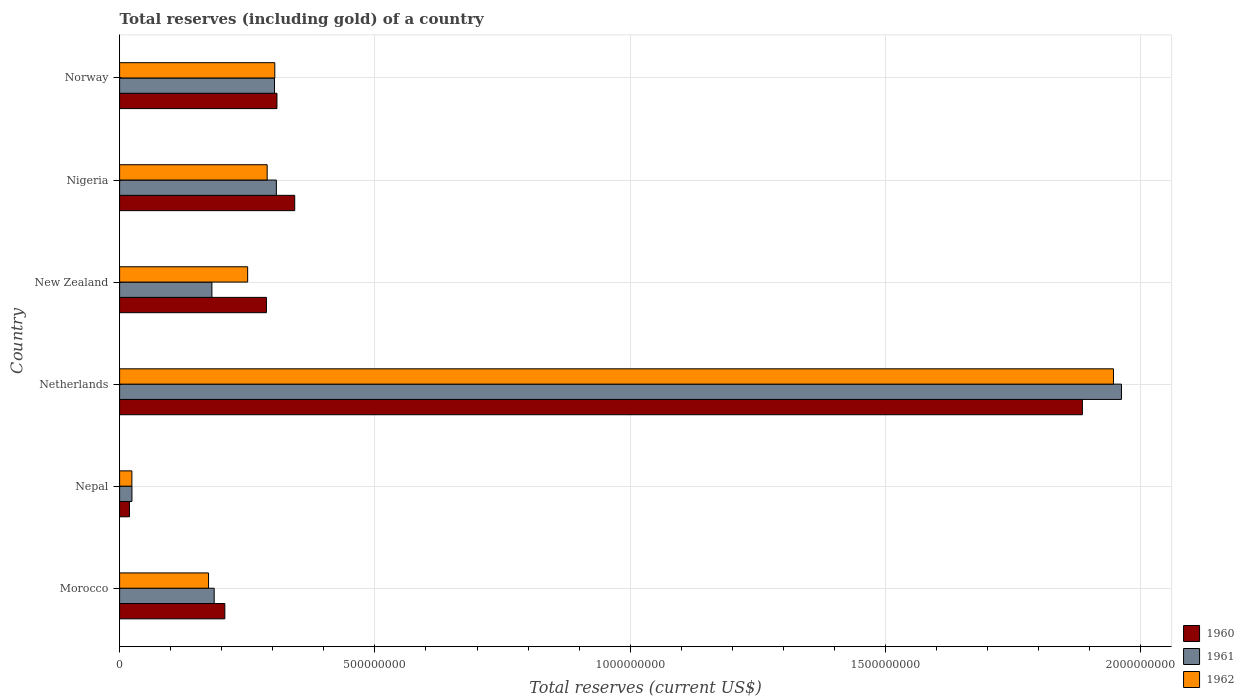How many groups of bars are there?
Provide a short and direct response. 6. How many bars are there on the 3rd tick from the bottom?
Ensure brevity in your answer.  3. What is the total reserves (including gold) in 1961 in Norway?
Provide a succinct answer. 3.03e+08. Across all countries, what is the maximum total reserves (including gold) in 1961?
Offer a terse response. 1.96e+09. Across all countries, what is the minimum total reserves (including gold) in 1960?
Your answer should be very brief. 1.93e+07. In which country was the total reserves (including gold) in 1961 minimum?
Give a very brief answer. Nepal. What is the total total reserves (including gold) in 1961 in the graph?
Your response must be concise. 2.96e+09. What is the difference between the total reserves (including gold) in 1962 in Nigeria and that in Norway?
Make the answer very short. -1.50e+07. What is the difference between the total reserves (including gold) in 1961 in Netherlands and the total reserves (including gold) in 1960 in Nepal?
Make the answer very short. 1.94e+09. What is the average total reserves (including gold) in 1960 per country?
Keep it short and to the point. 5.08e+08. What is the difference between the total reserves (including gold) in 1961 and total reserves (including gold) in 1960 in Nepal?
Your answer should be very brief. 4.88e+06. What is the ratio of the total reserves (including gold) in 1961 in Morocco to that in Norway?
Your answer should be compact. 0.61. Is the total reserves (including gold) in 1961 in Morocco less than that in Nigeria?
Offer a terse response. Yes. Is the difference between the total reserves (including gold) in 1961 in Nepal and Norway greater than the difference between the total reserves (including gold) in 1960 in Nepal and Norway?
Ensure brevity in your answer.  Yes. What is the difference between the highest and the second highest total reserves (including gold) in 1961?
Offer a terse response. 1.66e+09. What is the difference between the highest and the lowest total reserves (including gold) in 1962?
Keep it short and to the point. 1.92e+09. In how many countries, is the total reserves (including gold) in 1961 greater than the average total reserves (including gold) in 1961 taken over all countries?
Keep it short and to the point. 1. What does the 1st bar from the top in Netherlands represents?
Ensure brevity in your answer.  1962. What does the 2nd bar from the bottom in Netherlands represents?
Give a very brief answer. 1961. Is it the case that in every country, the sum of the total reserves (including gold) in 1962 and total reserves (including gold) in 1961 is greater than the total reserves (including gold) in 1960?
Keep it short and to the point. Yes. How many bars are there?
Provide a short and direct response. 18. What is the difference between two consecutive major ticks on the X-axis?
Your response must be concise. 5.00e+08. Does the graph contain any zero values?
Keep it short and to the point. No. How are the legend labels stacked?
Provide a short and direct response. Vertical. What is the title of the graph?
Make the answer very short. Total reserves (including gold) of a country. What is the label or title of the X-axis?
Your answer should be very brief. Total reserves (current US$). What is the label or title of the Y-axis?
Your answer should be compact. Country. What is the Total reserves (current US$) of 1960 in Morocco?
Provide a succinct answer. 2.06e+08. What is the Total reserves (current US$) of 1961 in Morocco?
Your answer should be very brief. 1.85e+08. What is the Total reserves (current US$) in 1962 in Morocco?
Keep it short and to the point. 1.74e+08. What is the Total reserves (current US$) of 1960 in Nepal?
Keep it short and to the point. 1.93e+07. What is the Total reserves (current US$) of 1961 in Nepal?
Provide a short and direct response. 2.41e+07. What is the Total reserves (current US$) of 1962 in Nepal?
Ensure brevity in your answer.  2.40e+07. What is the Total reserves (current US$) in 1960 in Netherlands?
Offer a very short reply. 1.89e+09. What is the Total reserves (current US$) in 1961 in Netherlands?
Give a very brief answer. 1.96e+09. What is the Total reserves (current US$) of 1962 in Netherlands?
Ensure brevity in your answer.  1.95e+09. What is the Total reserves (current US$) of 1960 in New Zealand?
Your response must be concise. 2.88e+08. What is the Total reserves (current US$) in 1961 in New Zealand?
Provide a short and direct response. 1.81e+08. What is the Total reserves (current US$) in 1962 in New Zealand?
Offer a very short reply. 2.51e+08. What is the Total reserves (current US$) in 1960 in Nigeria?
Offer a terse response. 3.43e+08. What is the Total reserves (current US$) of 1961 in Nigeria?
Offer a very short reply. 3.07e+08. What is the Total reserves (current US$) in 1962 in Nigeria?
Make the answer very short. 2.89e+08. What is the Total reserves (current US$) of 1960 in Norway?
Your response must be concise. 3.08e+08. What is the Total reserves (current US$) of 1961 in Norway?
Offer a very short reply. 3.03e+08. What is the Total reserves (current US$) in 1962 in Norway?
Ensure brevity in your answer.  3.04e+08. Across all countries, what is the maximum Total reserves (current US$) of 1960?
Offer a very short reply. 1.89e+09. Across all countries, what is the maximum Total reserves (current US$) in 1961?
Make the answer very short. 1.96e+09. Across all countries, what is the maximum Total reserves (current US$) of 1962?
Your answer should be compact. 1.95e+09. Across all countries, what is the minimum Total reserves (current US$) in 1960?
Your answer should be very brief. 1.93e+07. Across all countries, what is the minimum Total reserves (current US$) of 1961?
Your response must be concise. 2.41e+07. Across all countries, what is the minimum Total reserves (current US$) of 1962?
Provide a succinct answer. 2.40e+07. What is the total Total reserves (current US$) in 1960 in the graph?
Your answer should be compact. 3.05e+09. What is the total Total reserves (current US$) in 1961 in the graph?
Ensure brevity in your answer.  2.96e+09. What is the total Total reserves (current US$) of 1962 in the graph?
Give a very brief answer. 2.99e+09. What is the difference between the Total reserves (current US$) of 1960 in Morocco and that in Nepal?
Provide a short and direct response. 1.87e+08. What is the difference between the Total reserves (current US$) in 1961 in Morocco and that in Nepal?
Your response must be concise. 1.61e+08. What is the difference between the Total reserves (current US$) of 1962 in Morocco and that in Nepal?
Provide a succinct answer. 1.50e+08. What is the difference between the Total reserves (current US$) of 1960 in Morocco and that in Netherlands?
Your response must be concise. -1.68e+09. What is the difference between the Total reserves (current US$) of 1961 in Morocco and that in Netherlands?
Your response must be concise. -1.78e+09. What is the difference between the Total reserves (current US$) in 1962 in Morocco and that in Netherlands?
Ensure brevity in your answer.  -1.77e+09. What is the difference between the Total reserves (current US$) of 1960 in Morocco and that in New Zealand?
Provide a succinct answer. -8.15e+07. What is the difference between the Total reserves (current US$) of 1961 in Morocco and that in New Zealand?
Ensure brevity in your answer.  4.47e+06. What is the difference between the Total reserves (current US$) in 1962 in Morocco and that in New Zealand?
Provide a short and direct response. -7.66e+07. What is the difference between the Total reserves (current US$) in 1960 in Morocco and that in Nigeria?
Offer a very short reply. -1.37e+08. What is the difference between the Total reserves (current US$) in 1961 in Morocco and that in Nigeria?
Ensure brevity in your answer.  -1.22e+08. What is the difference between the Total reserves (current US$) in 1962 in Morocco and that in Nigeria?
Your answer should be compact. -1.15e+08. What is the difference between the Total reserves (current US$) of 1960 in Morocco and that in Norway?
Provide a succinct answer. -1.02e+08. What is the difference between the Total reserves (current US$) of 1961 in Morocco and that in Norway?
Give a very brief answer. -1.18e+08. What is the difference between the Total reserves (current US$) in 1962 in Morocco and that in Norway?
Provide a succinct answer. -1.30e+08. What is the difference between the Total reserves (current US$) in 1960 in Nepal and that in Netherlands?
Provide a succinct answer. -1.87e+09. What is the difference between the Total reserves (current US$) of 1961 in Nepal and that in Netherlands?
Offer a very short reply. -1.94e+09. What is the difference between the Total reserves (current US$) of 1962 in Nepal and that in Netherlands?
Offer a terse response. -1.92e+09. What is the difference between the Total reserves (current US$) in 1960 in Nepal and that in New Zealand?
Your answer should be very brief. -2.68e+08. What is the difference between the Total reserves (current US$) of 1961 in Nepal and that in New Zealand?
Your answer should be very brief. -1.57e+08. What is the difference between the Total reserves (current US$) of 1962 in Nepal and that in New Zealand?
Your answer should be very brief. -2.27e+08. What is the difference between the Total reserves (current US$) of 1960 in Nepal and that in Nigeria?
Keep it short and to the point. -3.24e+08. What is the difference between the Total reserves (current US$) of 1961 in Nepal and that in Nigeria?
Keep it short and to the point. -2.83e+08. What is the difference between the Total reserves (current US$) in 1962 in Nepal and that in Nigeria?
Ensure brevity in your answer.  -2.65e+08. What is the difference between the Total reserves (current US$) of 1960 in Nepal and that in Norway?
Give a very brief answer. -2.89e+08. What is the difference between the Total reserves (current US$) in 1961 in Nepal and that in Norway?
Ensure brevity in your answer.  -2.79e+08. What is the difference between the Total reserves (current US$) in 1962 in Nepal and that in Norway?
Provide a succinct answer. -2.80e+08. What is the difference between the Total reserves (current US$) in 1960 in Netherlands and that in New Zealand?
Your answer should be very brief. 1.60e+09. What is the difference between the Total reserves (current US$) of 1961 in Netherlands and that in New Zealand?
Offer a terse response. 1.78e+09. What is the difference between the Total reserves (current US$) in 1962 in Netherlands and that in New Zealand?
Your response must be concise. 1.70e+09. What is the difference between the Total reserves (current US$) in 1960 in Netherlands and that in Nigeria?
Offer a very short reply. 1.54e+09. What is the difference between the Total reserves (current US$) of 1961 in Netherlands and that in Nigeria?
Offer a very short reply. 1.66e+09. What is the difference between the Total reserves (current US$) of 1962 in Netherlands and that in Nigeria?
Your answer should be very brief. 1.66e+09. What is the difference between the Total reserves (current US$) of 1960 in Netherlands and that in Norway?
Keep it short and to the point. 1.58e+09. What is the difference between the Total reserves (current US$) in 1961 in Netherlands and that in Norway?
Offer a very short reply. 1.66e+09. What is the difference between the Total reserves (current US$) in 1962 in Netherlands and that in Norway?
Ensure brevity in your answer.  1.64e+09. What is the difference between the Total reserves (current US$) of 1960 in New Zealand and that in Nigeria?
Keep it short and to the point. -5.54e+07. What is the difference between the Total reserves (current US$) in 1961 in New Zealand and that in Nigeria?
Your answer should be very brief. -1.26e+08. What is the difference between the Total reserves (current US$) of 1962 in New Zealand and that in Nigeria?
Offer a very short reply. -3.82e+07. What is the difference between the Total reserves (current US$) in 1960 in New Zealand and that in Norway?
Give a very brief answer. -2.06e+07. What is the difference between the Total reserves (current US$) of 1961 in New Zealand and that in Norway?
Your answer should be compact. -1.23e+08. What is the difference between the Total reserves (current US$) in 1962 in New Zealand and that in Norway?
Provide a succinct answer. -5.32e+07. What is the difference between the Total reserves (current US$) in 1960 in Nigeria and that in Norway?
Your answer should be very brief. 3.48e+07. What is the difference between the Total reserves (current US$) in 1961 in Nigeria and that in Norway?
Provide a succinct answer. 3.64e+06. What is the difference between the Total reserves (current US$) of 1962 in Nigeria and that in Norway?
Provide a succinct answer. -1.50e+07. What is the difference between the Total reserves (current US$) of 1960 in Morocco and the Total reserves (current US$) of 1961 in Nepal?
Provide a short and direct response. 1.82e+08. What is the difference between the Total reserves (current US$) of 1960 in Morocco and the Total reserves (current US$) of 1962 in Nepal?
Your answer should be very brief. 1.82e+08. What is the difference between the Total reserves (current US$) of 1961 in Morocco and the Total reserves (current US$) of 1962 in Nepal?
Make the answer very short. 1.61e+08. What is the difference between the Total reserves (current US$) in 1960 in Morocco and the Total reserves (current US$) in 1961 in Netherlands?
Your answer should be very brief. -1.76e+09. What is the difference between the Total reserves (current US$) in 1960 in Morocco and the Total reserves (current US$) in 1962 in Netherlands?
Keep it short and to the point. -1.74e+09. What is the difference between the Total reserves (current US$) in 1961 in Morocco and the Total reserves (current US$) in 1962 in Netherlands?
Your answer should be compact. -1.76e+09. What is the difference between the Total reserves (current US$) of 1960 in Morocco and the Total reserves (current US$) of 1961 in New Zealand?
Your answer should be very brief. 2.53e+07. What is the difference between the Total reserves (current US$) of 1960 in Morocco and the Total reserves (current US$) of 1962 in New Zealand?
Ensure brevity in your answer.  -4.47e+07. What is the difference between the Total reserves (current US$) of 1961 in Morocco and the Total reserves (current US$) of 1962 in New Zealand?
Offer a very short reply. -6.55e+07. What is the difference between the Total reserves (current US$) of 1960 in Morocco and the Total reserves (current US$) of 1961 in Nigeria?
Provide a succinct answer. -1.01e+08. What is the difference between the Total reserves (current US$) of 1960 in Morocco and the Total reserves (current US$) of 1962 in Nigeria?
Ensure brevity in your answer.  -8.29e+07. What is the difference between the Total reserves (current US$) of 1961 in Morocco and the Total reserves (current US$) of 1962 in Nigeria?
Make the answer very short. -1.04e+08. What is the difference between the Total reserves (current US$) in 1960 in Morocco and the Total reserves (current US$) in 1961 in Norway?
Your answer should be very brief. -9.73e+07. What is the difference between the Total reserves (current US$) of 1960 in Morocco and the Total reserves (current US$) of 1962 in Norway?
Your response must be concise. -9.79e+07. What is the difference between the Total reserves (current US$) of 1961 in Morocco and the Total reserves (current US$) of 1962 in Norway?
Your answer should be compact. -1.19e+08. What is the difference between the Total reserves (current US$) of 1960 in Nepal and the Total reserves (current US$) of 1961 in Netherlands?
Your answer should be compact. -1.94e+09. What is the difference between the Total reserves (current US$) in 1960 in Nepal and the Total reserves (current US$) in 1962 in Netherlands?
Provide a short and direct response. -1.93e+09. What is the difference between the Total reserves (current US$) of 1961 in Nepal and the Total reserves (current US$) of 1962 in Netherlands?
Your response must be concise. -1.92e+09. What is the difference between the Total reserves (current US$) in 1960 in Nepal and the Total reserves (current US$) in 1961 in New Zealand?
Keep it short and to the point. -1.62e+08. What is the difference between the Total reserves (current US$) in 1960 in Nepal and the Total reserves (current US$) in 1962 in New Zealand?
Your answer should be compact. -2.32e+08. What is the difference between the Total reserves (current US$) of 1961 in Nepal and the Total reserves (current US$) of 1962 in New Zealand?
Your answer should be very brief. -2.27e+08. What is the difference between the Total reserves (current US$) in 1960 in Nepal and the Total reserves (current US$) in 1961 in Nigeria?
Your answer should be compact. -2.88e+08. What is the difference between the Total reserves (current US$) in 1960 in Nepal and the Total reserves (current US$) in 1962 in Nigeria?
Your answer should be compact. -2.70e+08. What is the difference between the Total reserves (current US$) in 1961 in Nepal and the Total reserves (current US$) in 1962 in Nigeria?
Provide a succinct answer. -2.65e+08. What is the difference between the Total reserves (current US$) in 1960 in Nepal and the Total reserves (current US$) in 1961 in Norway?
Your answer should be compact. -2.84e+08. What is the difference between the Total reserves (current US$) of 1960 in Nepal and the Total reserves (current US$) of 1962 in Norway?
Your response must be concise. -2.85e+08. What is the difference between the Total reserves (current US$) of 1961 in Nepal and the Total reserves (current US$) of 1962 in Norway?
Provide a short and direct response. -2.80e+08. What is the difference between the Total reserves (current US$) of 1960 in Netherlands and the Total reserves (current US$) of 1961 in New Zealand?
Offer a terse response. 1.70e+09. What is the difference between the Total reserves (current US$) in 1960 in Netherlands and the Total reserves (current US$) in 1962 in New Zealand?
Give a very brief answer. 1.63e+09. What is the difference between the Total reserves (current US$) of 1961 in Netherlands and the Total reserves (current US$) of 1962 in New Zealand?
Give a very brief answer. 1.71e+09. What is the difference between the Total reserves (current US$) of 1960 in Netherlands and the Total reserves (current US$) of 1961 in Nigeria?
Your response must be concise. 1.58e+09. What is the difference between the Total reserves (current US$) in 1960 in Netherlands and the Total reserves (current US$) in 1962 in Nigeria?
Provide a short and direct response. 1.60e+09. What is the difference between the Total reserves (current US$) of 1961 in Netherlands and the Total reserves (current US$) of 1962 in Nigeria?
Ensure brevity in your answer.  1.67e+09. What is the difference between the Total reserves (current US$) of 1960 in Netherlands and the Total reserves (current US$) of 1961 in Norway?
Your response must be concise. 1.58e+09. What is the difference between the Total reserves (current US$) in 1960 in Netherlands and the Total reserves (current US$) in 1962 in Norway?
Provide a short and direct response. 1.58e+09. What is the difference between the Total reserves (current US$) in 1961 in Netherlands and the Total reserves (current US$) in 1962 in Norway?
Provide a short and direct response. 1.66e+09. What is the difference between the Total reserves (current US$) in 1960 in New Zealand and the Total reserves (current US$) in 1961 in Nigeria?
Offer a very short reply. -1.95e+07. What is the difference between the Total reserves (current US$) in 1960 in New Zealand and the Total reserves (current US$) in 1962 in Nigeria?
Your answer should be very brief. -1.43e+06. What is the difference between the Total reserves (current US$) in 1961 in New Zealand and the Total reserves (current US$) in 1962 in Nigeria?
Offer a very short reply. -1.08e+08. What is the difference between the Total reserves (current US$) in 1960 in New Zealand and the Total reserves (current US$) in 1961 in Norway?
Your answer should be compact. -1.58e+07. What is the difference between the Total reserves (current US$) in 1960 in New Zealand and the Total reserves (current US$) in 1962 in Norway?
Offer a very short reply. -1.64e+07. What is the difference between the Total reserves (current US$) in 1961 in New Zealand and the Total reserves (current US$) in 1962 in Norway?
Your answer should be very brief. -1.23e+08. What is the difference between the Total reserves (current US$) of 1960 in Nigeria and the Total reserves (current US$) of 1961 in Norway?
Offer a terse response. 3.96e+07. What is the difference between the Total reserves (current US$) in 1960 in Nigeria and the Total reserves (current US$) in 1962 in Norway?
Provide a short and direct response. 3.90e+07. What is the difference between the Total reserves (current US$) of 1961 in Nigeria and the Total reserves (current US$) of 1962 in Norway?
Provide a succinct answer. 3.09e+06. What is the average Total reserves (current US$) in 1960 per country?
Offer a very short reply. 5.08e+08. What is the average Total reserves (current US$) of 1961 per country?
Your response must be concise. 4.94e+08. What is the average Total reserves (current US$) in 1962 per country?
Provide a short and direct response. 4.98e+08. What is the difference between the Total reserves (current US$) in 1960 and Total reserves (current US$) in 1961 in Morocco?
Your answer should be compact. 2.08e+07. What is the difference between the Total reserves (current US$) in 1960 and Total reserves (current US$) in 1962 in Morocco?
Your response must be concise. 3.19e+07. What is the difference between the Total reserves (current US$) in 1961 and Total reserves (current US$) in 1962 in Morocco?
Your answer should be compact. 1.11e+07. What is the difference between the Total reserves (current US$) of 1960 and Total reserves (current US$) of 1961 in Nepal?
Ensure brevity in your answer.  -4.88e+06. What is the difference between the Total reserves (current US$) in 1960 and Total reserves (current US$) in 1962 in Nepal?
Offer a very short reply. -4.77e+06. What is the difference between the Total reserves (current US$) of 1961 and Total reserves (current US$) of 1962 in Nepal?
Your response must be concise. 1.04e+05. What is the difference between the Total reserves (current US$) of 1960 and Total reserves (current US$) of 1961 in Netherlands?
Make the answer very short. -7.65e+07. What is the difference between the Total reserves (current US$) of 1960 and Total reserves (current US$) of 1962 in Netherlands?
Provide a succinct answer. -6.09e+07. What is the difference between the Total reserves (current US$) of 1961 and Total reserves (current US$) of 1962 in Netherlands?
Offer a terse response. 1.56e+07. What is the difference between the Total reserves (current US$) of 1960 and Total reserves (current US$) of 1961 in New Zealand?
Give a very brief answer. 1.07e+08. What is the difference between the Total reserves (current US$) in 1960 and Total reserves (current US$) in 1962 in New Zealand?
Make the answer very short. 3.68e+07. What is the difference between the Total reserves (current US$) in 1961 and Total reserves (current US$) in 1962 in New Zealand?
Ensure brevity in your answer.  -7.00e+07. What is the difference between the Total reserves (current US$) of 1960 and Total reserves (current US$) of 1961 in Nigeria?
Keep it short and to the point. 3.59e+07. What is the difference between the Total reserves (current US$) of 1960 and Total reserves (current US$) of 1962 in Nigeria?
Offer a terse response. 5.40e+07. What is the difference between the Total reserves (current US$) of 1961 and Total reserves (current US$) of 1962 in Nigeria?
Your answer should be compact. 1.80e+07. What is the difference between the Total reserves (current US$) in 1960 and Total reserves (current US$) in 1961 in Norway?
Make the answer very short. 4.75e+06. What is the difference between the Total reserves (current US$) of 1960 and Total reserves (current US$) of 1962 in Norway?
Provide a short and direct response. 4.20e+06. What is the difference between the Total reserves (current US$) in 1961 and Total reserves (current US$) in 1962 in Norway?
Provide a succinct answer. -5.46e+05. What is the ratio of the Total reserves (current US$) in 1960 in Morocco to that in Nepal?
Your response must be concise. 10.69. What is the ratio of the Total reserves (current US$) of 1961 in Morocco to that in Nepal?
Provide a short and direct response. 7.67. What is the ratio of the Total reserves (current US$) in 1962 in Morocco to that in Nepal?
Offer a very short reply. 7.24. What is the ratio of the Total reserves (current US$) in 1960 in Morocco to that in Netherlands?
Keep it short and to the point. 0.11. What is the ratio of the Total reserves (current US$) in 1961 in Morocco to that in Netherlands?
Provide a short and direct response. 0.09. What is the ratio of the Total reserves (current US$) of 1962 in Morocco to that in Netherlands?
Offer a very short reply. 0.09. What is the ratio of the Total reserves (current US$) in 1960 in Morocco to that in New Zealand?
Provide a succinct answer. 0.72. What is the ratio of the Total reserves (current US$) in 1961 in Morocco to that in New Zealand?
Provide a succinct answer. 1.02. What is the ratio of the Total reserves (current US$) of 1962 in Morocco to that in New Zealand?
Give a very brief answer. 0.69. What is the ratio of the Total reserves (current US$) in 1960 in Morocco to that in Nigeria?
Your response must be concise. 0.6. What is the ratio of the Total reserves (current US$) of 1961 in Morocco to that in Nigeria?
Provide a succinct answer. 0.6. What is the ratio of the Total reserves (current US$) in 1962 in Morocco to that in Nigeria?
Offer a terse response. 0.6. What is the ratio of the Total reserves (current US$) in 1960 in Morocco to that in Norway?
Give a very brief answer. 0.67. What is the ratio of the Total reserves (current US$) in 1961 in Morocco to that in Norway?
Offer a terse response. 0.61. What is the ratio of the Total reserves (current US$) in 1962 in Morocco to that in Norway?
Ensure brevity in your answer.  0.57. What is the ratio of the Total reserves (current US$) in 1960 in Nepal to that in Netherlands?
Give a very brief answer. 0.01. What is the ratio of the Total reserves (current US$) in 1961 in Nepal to that in Netherlands?
Provide a succinct answer. 0.01. What is the ratio of the Total reserves (current US$) in 1962 in Nepal to that in Netherlands?
Ensure brevity in your answer.  0.01. What is the ratio of the Total reserves (current US$) in 1960 in Nepal to that in New Zealand?
Keep it short and to the point. 0.07. What is the ratio of the Total reserves (current US$) of 1961 in Nepal to that in New Zealand?
Offer a terse response. 0.13. What is the ratio of the Total reserves (current US$) of 1962 in Nepal to that in New Zealand?
Provide a short and direct response. 0.1. What is the ratio of the Total reserves (current US$) in 1960 in Nepal to that in Nigeria?
Provide a short and direct response. 0.06. What is the ratio of the Total reserves (current US$) in 1961 in Nepal to that in Nigeria?
Your answer should be very brief. 0.08. What is the ratio of the Total reserves (current US$) of 1962 in Nepal to that in Nigeria?
Ensure brevity in your answer.  0.08. What is the ratio of the Total reserves (current US$) in 1960 in Nepal to that in Norway?
Provide a succinct answer. 0.06. What is the ratio of the Total reserves (current US$) in 1961 in Nepal to that in Norway?
Offer a very short reply. 0.08. What is the ratio of the Total reserves (current US$) of 1962 in Nepal to that in Norway?
Provide a short and direct response. 0.08. What is the ratio of the Total reserves (current US$) of 1960 in Netherlands to that in New Zealand?
Offer a terse response. 6.56. What is the ratio of the Total reserves (current US$) of 1961 in Netherlands to that in New Zealand?
Offer a terse response. 10.85. What is the ratio of the Total reserves (current US$) of 1962 in Netherlands to that in New Zealand?
Offer a very short reply. 7.76. What is the ratio of the Total reserves (current US$) in 1960 in Netherlands to that in Nigeria?
Keep it short and to the point. 5.5. What is the ratio of the Total reserves (current US$) in 1961 in Netherlands to that in Nigeria?
Provide a succinct answer. 6.39. What is the ratio of the Total reserves (current US$) of 1962 in Netherlands to that in Nigeria?
Keep it short and to the point. 6.74. What is the ratio of the Total reserves (current US$) of 1960 in Netherlands to that in Norway?
Your answer should be compact. 6.12. What is the ratio of the Total reserves (current US$) of 1961 in Netherlands to that in Norway?
Provide a succinct answer. 6.47. What is the ratio of the Total reserves (current US$) of 1962 in Netherlands to that in Norway?
Provide a succinct answer. 6.4. What is the ratio of the Total reserves (current US$) in 1960 in New Zealand to that in Nigeria?
Your answer should be compact. 0.84. What is the ratio of the Total reserves (current US$) in 1961 in New Zealand to that in Nigeria?
Offer a terse response. 0.59. What is the ratio of the Total reserves (current US$) in 1962 in New Zealand to that in Nigeria?
Keep it short and to the point. 0.87. What is the ratio of the Total reserves (current US$) in 1960 in New Zealand to that in Norway?
Keep it short and to the point. 0.93. What is the ratio of the Total reserves (current US$) in 1961 in New Zealand to that in Norway?
Offer a very short reply. 0.6. What is the ratio of the Total reserves (current US$) in 1962 in New Zealand to that in Norway?
Provide a short and direct response. 0.83. What is the ratio of the Total reserves (current US$) in 1960 in Nigeria to that in Norway?
Offer a terse response. 1.11. What is the ratio of the Total reserves (current US$) of 1961 in Nigeria to that in Norway?
Offer a very short reply. 1.01. What is the ratio of the Total reserves (current US$) in 1962 in Nigeria to that in Norway?
Ensure brevity in your answer.  0.95. What is the difference between the highest and the second highest Total reserves (current US$) of 1960?
Offer a very short reply. 1.54e+09. What is the difference between the highest and the second highest Total reserves (current US$) in 1961?
Provide a short and direct response. 1.66e+09. What is the difference between the highest and the second highest Total reserves (current US$) in 1962?
Make the answer very short. 1.64e+09. What is the difference between the highest and the lowest Total reserves (current US$) in 1960?
Make the answer very short. 1.87e+09. What is the difference between the highest and the lowest Total reserves (current US$) of 1961?
Your answer should be compact. 1.94e+09. What is the difference between the highest and the lowest Total reserves (current US$) of 1962?
Your answer should be very brief. 1.92e+09. 